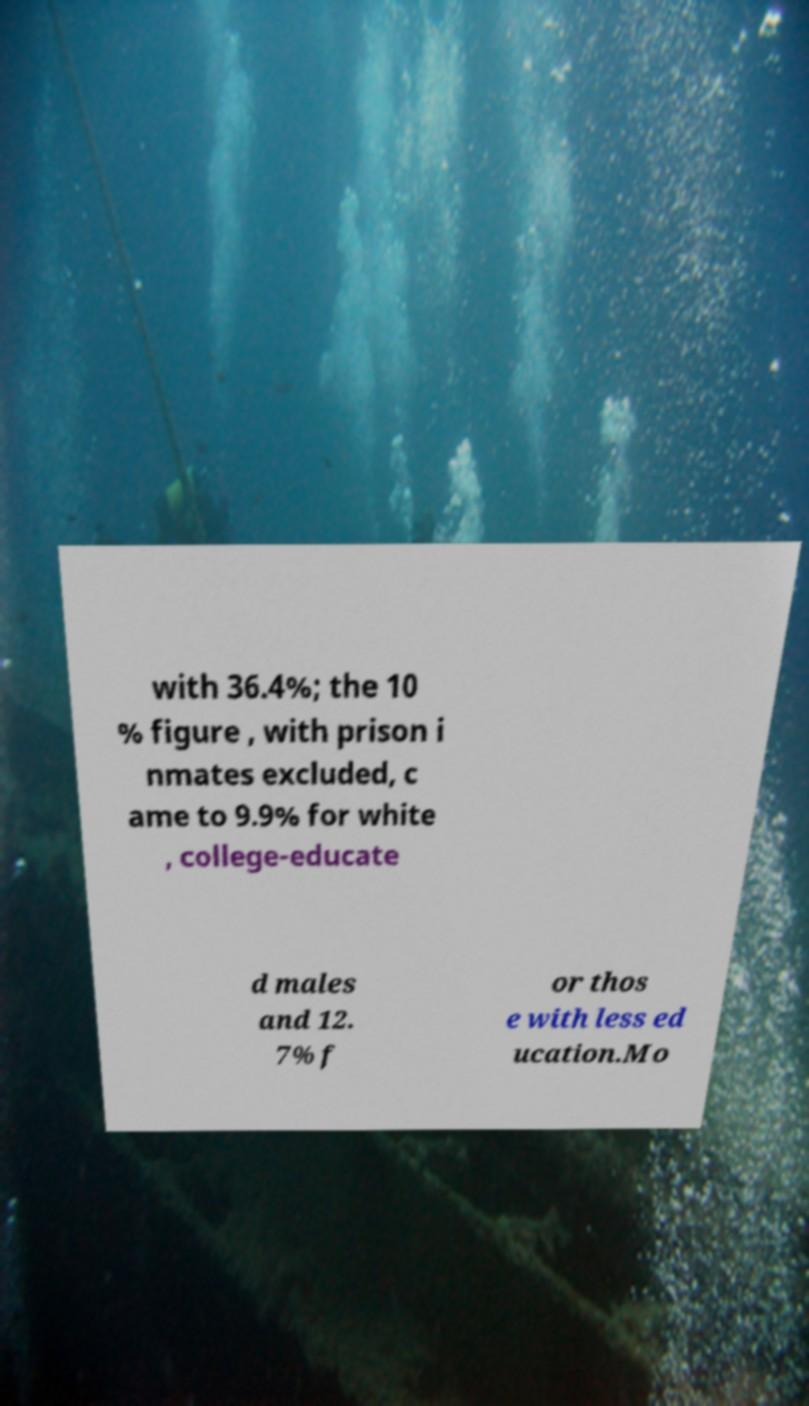Can you accurately transcribe the text from the provided image for me? with 36.4%; the 10 % figure , with prison i nmates excluded, c ame to 9.9% for white , college-educate d males and 12. 7% f or thos e with less ed ucation.Mo 